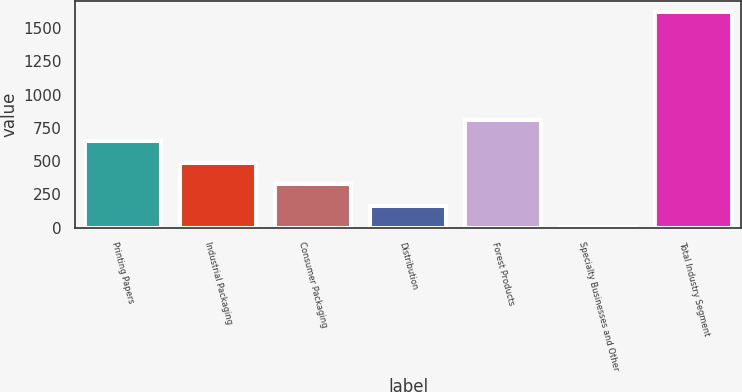Convert chart to OTSL. <chart><loc_0><loc_0><loc_500><loc_500><bar_chart><fcel>Printing Papers<fcel>Industrial Packaging<fcel>Consumer Packaging<fcel>Distribution<fcel>Forest Products<fcel>Specialty Businesses and Other<fcel>Total Industry Segment<nl><fcel>651.2<fcel>489.4<fcel>327.6<fcel>165.8<fcel>813<fcel>4<fcel>1622<nl></chart> 